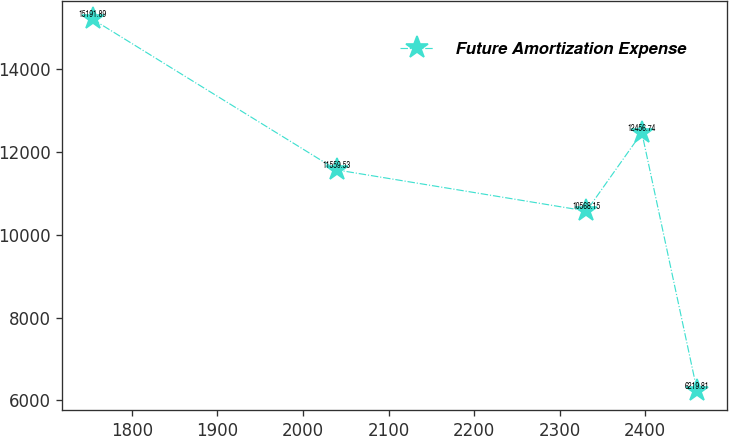<chart> <loc_0><loc_0><loc_500><loc_500><line_chart><ecel><fcel>Future Amortization Expense<nl><fcel>1754.16<fcel>15191.9<nl><fcel>2039.41<fcel>11559.5<nl><fcel>2331.3<fcel>10568.1<nl><fcel>2396.04<fcel>12456.7<nl><fcel>2460.78<fcel>6219.81<nl></chart> 